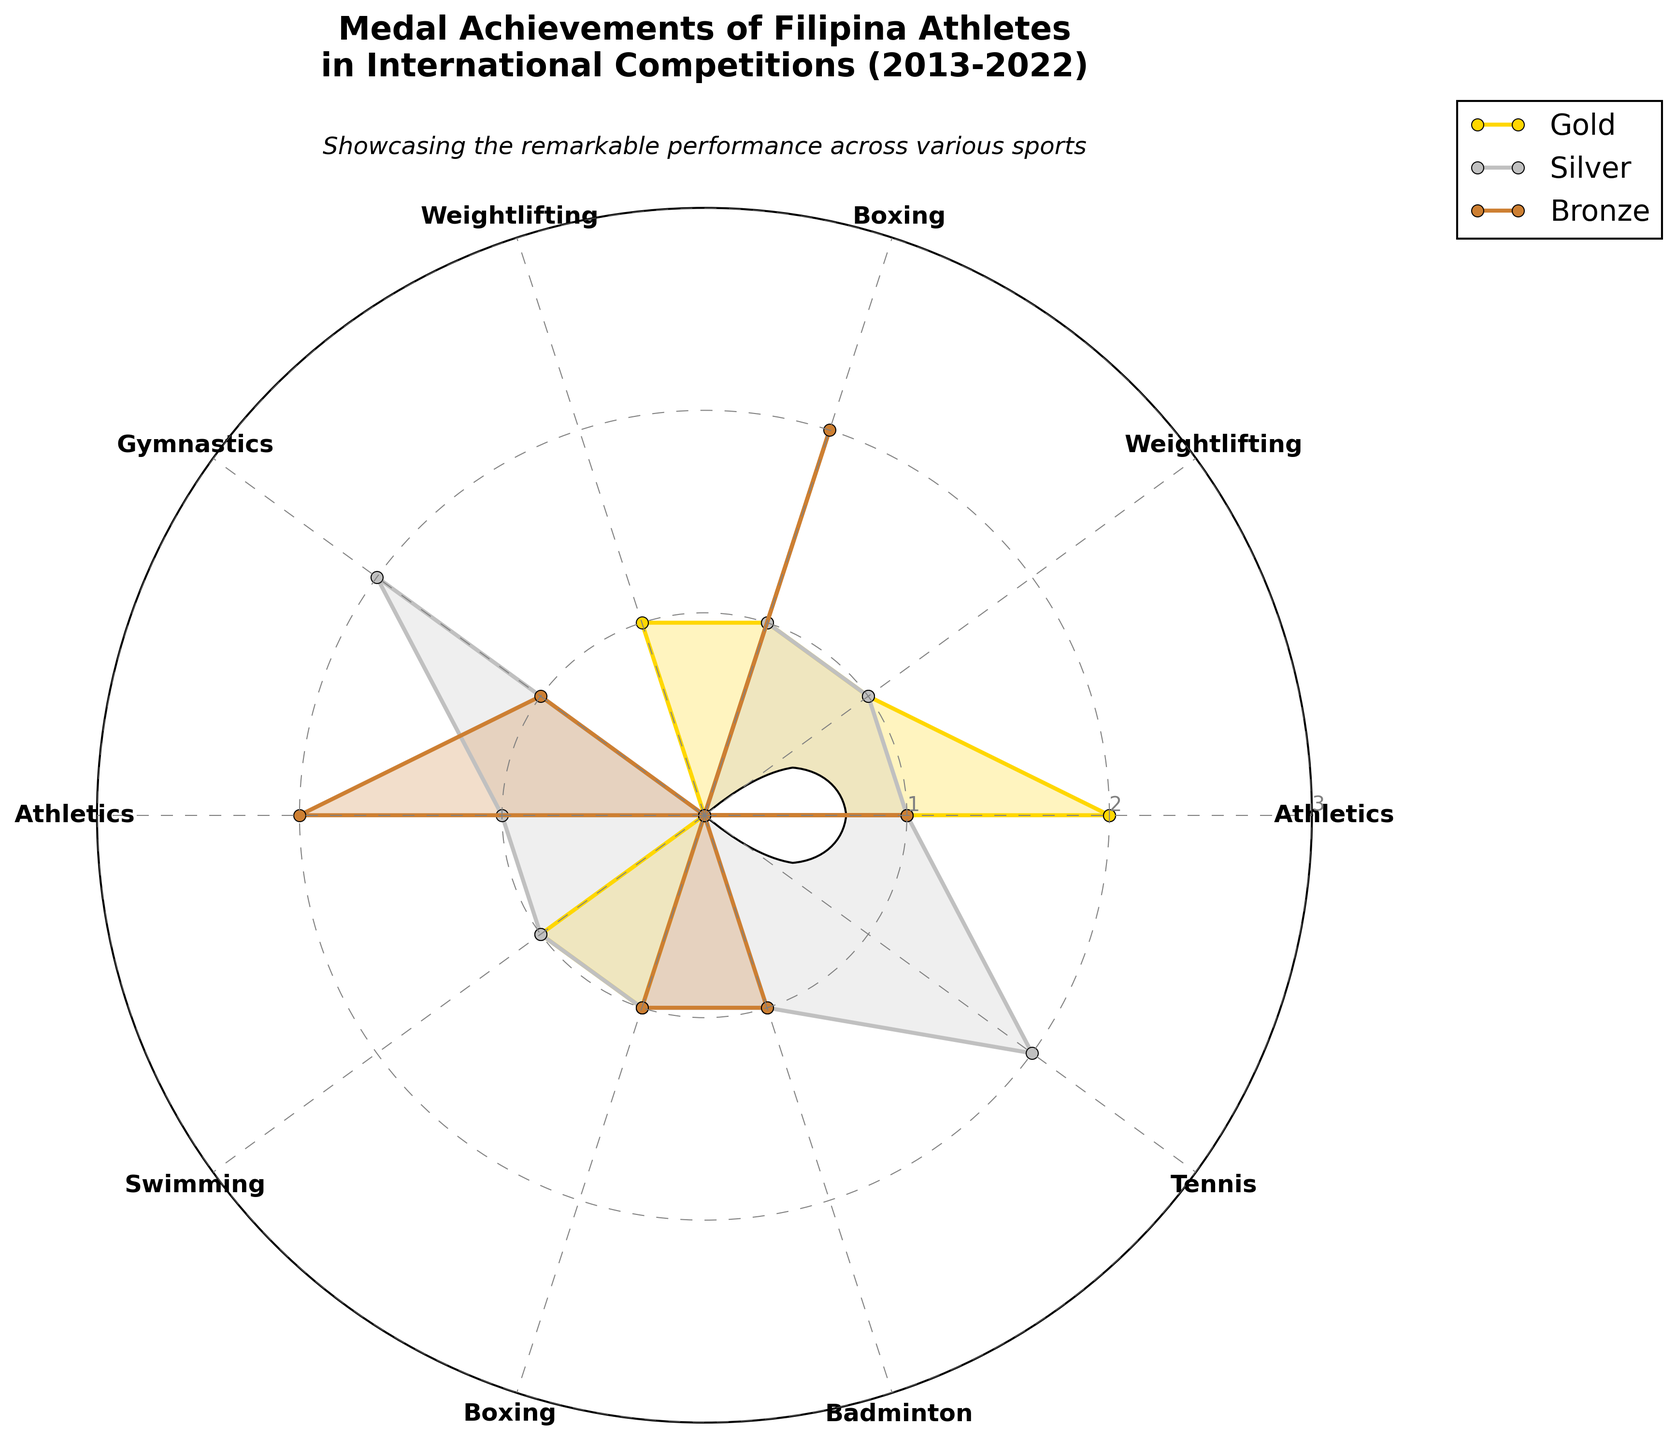How many gold medals were won in Athletics? Look at the section for Athletics and note the number of gold medals, which corresponds to the length of the gold-colored wedge.
Answer: 2 Which event brought home the most bronze medals? Compare the sizes of the bronze-colored wedges across all categories and identify the largest one.
Answer: Boxing What is the total number of silver medals won across all events? Sum up the silver medal values for each category: 1+1+1+0+2+1+1+2 = 9.
Answer: 9 Between Weightlifting and Gymnastics, which event saw a greater number of gold medals? Compare the size of the gold wedges for Weightlifting and Gymnastics. Weightlifting has more.
Answer: Weightlifting What is the combined total of medals (gold, silver, bronze) won in Badminton? Add up all the medal counts (gold, silver, and bronze) for Badminton: 0+1+1 = 2.
Answer: 2 Which event saw the most evenly distributed medal wins across all three types? Identify the category where the gold, silver, and bronze wedges are closest in size.
Answer: Boxing In which year did the athletes achieve the highest number of gold medals in a single event? Check the figure for the largest gold wedge and cross-reference with the data.
Answer: Athletics in the 2013 Southeast Asian Games What's the difference in the number of bronze medals between Athletics and Tennis? Subtract the number of bronze medals won in Tennis from those won in Athletics: 3-0 = 3.
Answer: 3 Which sports do not have any gold medals? Identify the categories without any gold-colored wedges.
Answer: Gymnastics, Athletics (Asian Games), Badminton, Tennis What event had the lowest total medal count? Determine the category with the smallest cumulative wedge sizes.
Answer: Tennis 